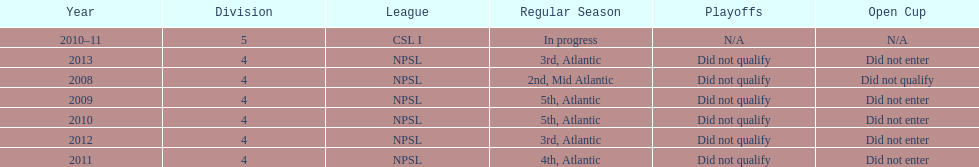Using the data, what should be the next year they will play? 2014. 